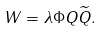<formula> <loc_0><loc_0><loc_500><loc_500>W = \lambda \Phi Q \widetilde { Q } .</formula> 